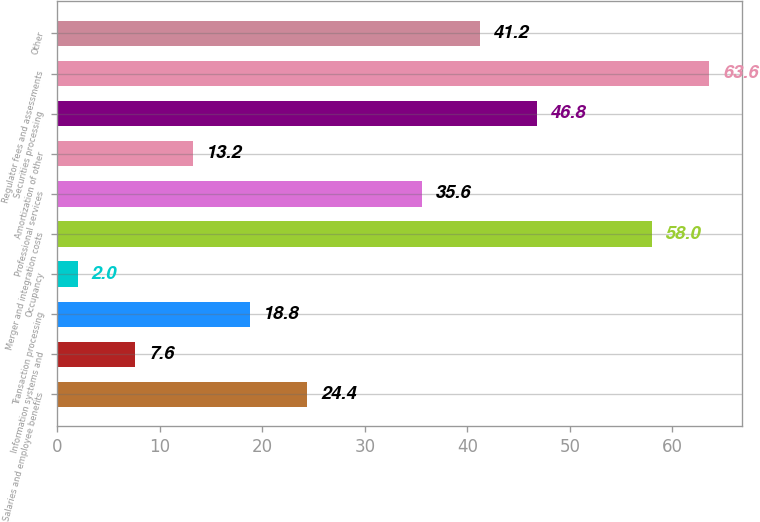<chart> <loc_0><loc_0><loc_500><loc_500><bar_chart><fcel>Salaries and employee benefits<fcel>Information systems and<fcel>Transaction processing<fcel>Occupancy<fcel>Merger and integration costs<fcel>Professional services<fcel>Amortization of other<fcel>Securities processing<fcel>Regulator fees and assessments<fcel>Other<nl><fcel>24.4<fcel>7.6<fcel>18.8<fcel>2<fcel>58<fcel>35.6<fcel>13.2<fcel>46.8<fcel>63.6<fcel>41.2<nl></chart> 